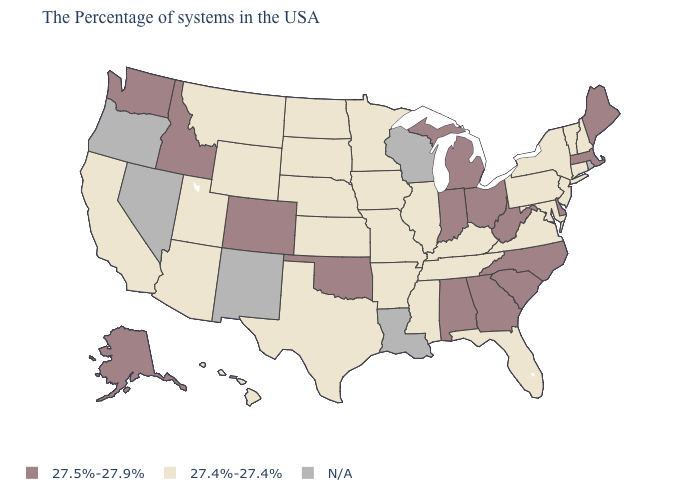Name the states that have a value in the range 27.4%-27.4%?
Quick response, please. New Hampshire, Vermont, Connecticut, New York, New Jersey, Maryland, Pennsylvania, Virginia, Florida, Kentucky, Tennessee, Illinois, Mississippi, Missouri, Arkansas, Minnesota, Iowa, Kansas, Nebraska, Texas, South Dakota, North Dakota, Wyoming, Utah, Montana, Arizona, California, Hawaii. What is the highest value in the MidWest ?
Concise answer only. 27.5%-27.9%. What is the value of Iowa?
Concise answer only. 27.4%-27.4%. Among the states that border Oregon , which have the lowest value?
Answer briefly. California. What is the value of Connecticut?
Keep it brief. 27.4%-27.4%. Among the states that border Maryland , which have the highest value?
Quick response, please. Delaware, West Virginia. Which states hav the highest value in the Northeast?
Be succinct. Maine, Massachusetts. Which states have the highest value in the USA?
Give a very brief answer. Maine, Massachusetts, Delaware, North Carolina, South Carolina, West Virginia, Ohio, Georgia, Michigan, Indiana, Alabama, Oklahoma, Colorado, Idaho, Washington, Alaska. Name the states that have a value in the range 27.4%-27.4%?
Be succinct. New Hampshire, Vermont, Connecticut, New York, New Jersey, Maryland, Pennsylvania, Virginia, Florida, Kentucky, Tennessee, Illinois, Mississippi, Missouri, Arkansas, Minnesota, Iowa, Kansas, Nebraska, Texas, South Dakota, North Dakota, Wyoming, Utah, Montana, Arizona, California, Hawaii. What is the value of Oklahoma?
Be succinct. 27.5%-27.9%. Does New Jersey have the lowest value in the USA?
Write a very short answer. Yes. Among the states that border Oklahoma , which have the highest value?
Write a very short answer. Colorado. What is the value of Wisconsin?
Answer briefly. N/A. What is the value of Montana?
Concise answer only. 27.4%-27.4%. 